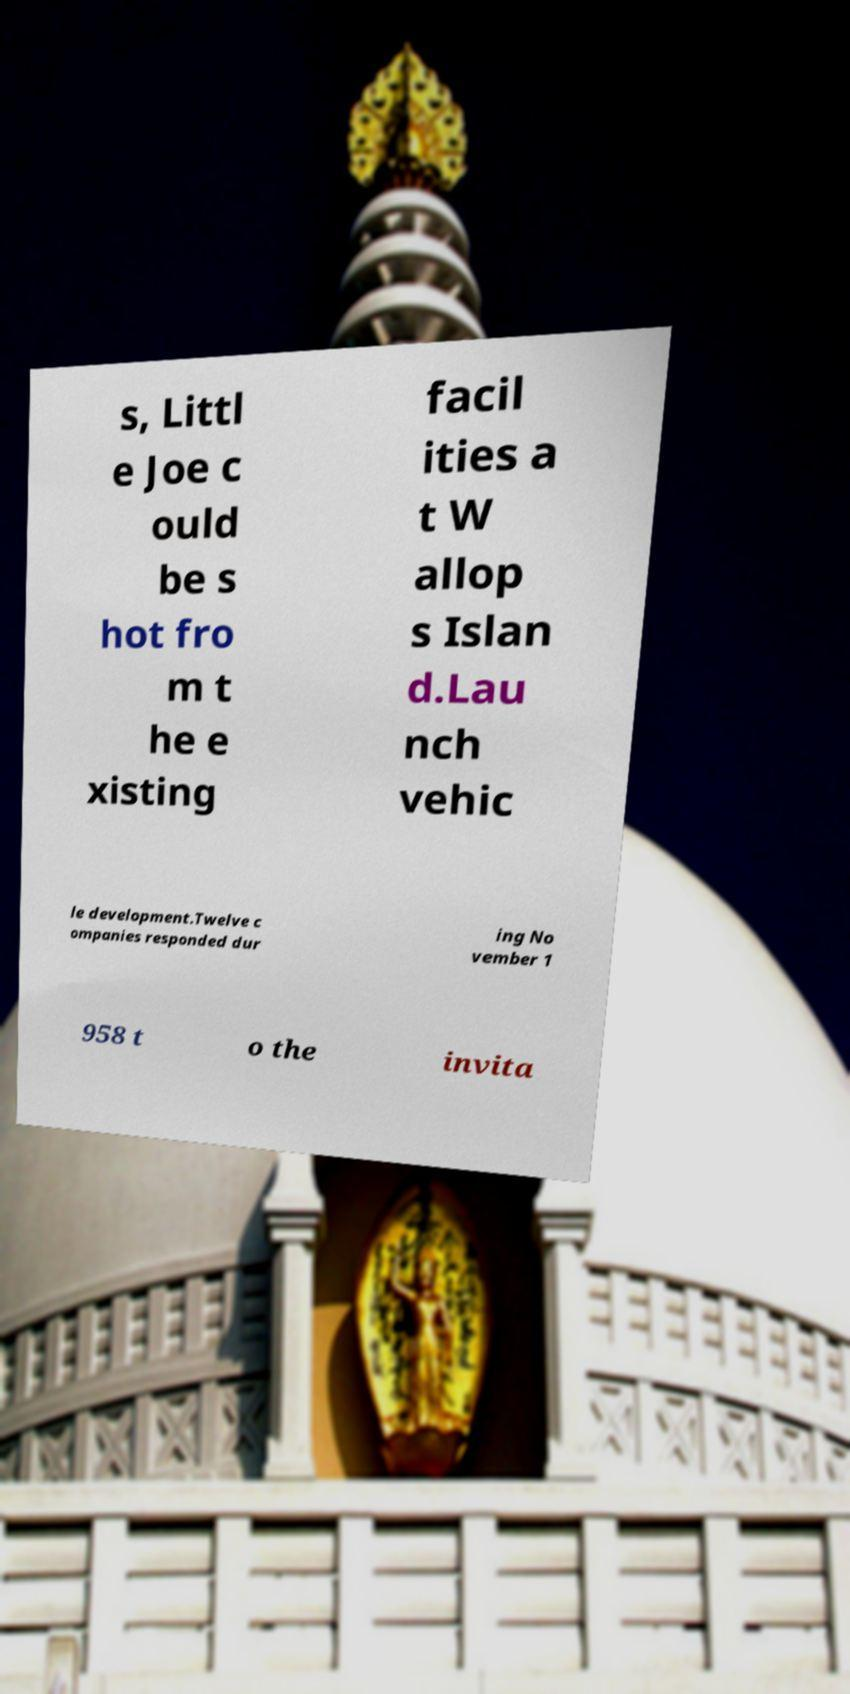What messages or text are displayed in this image? I need them in a readable, typed format. s, Littl e Joe c ould be s hot fro m t he e xisting facil ities a t W allop s Islan d.Lau nch vehic le development.Twelve c ompanies responded dur ing No vember 1 958 t o the invita 